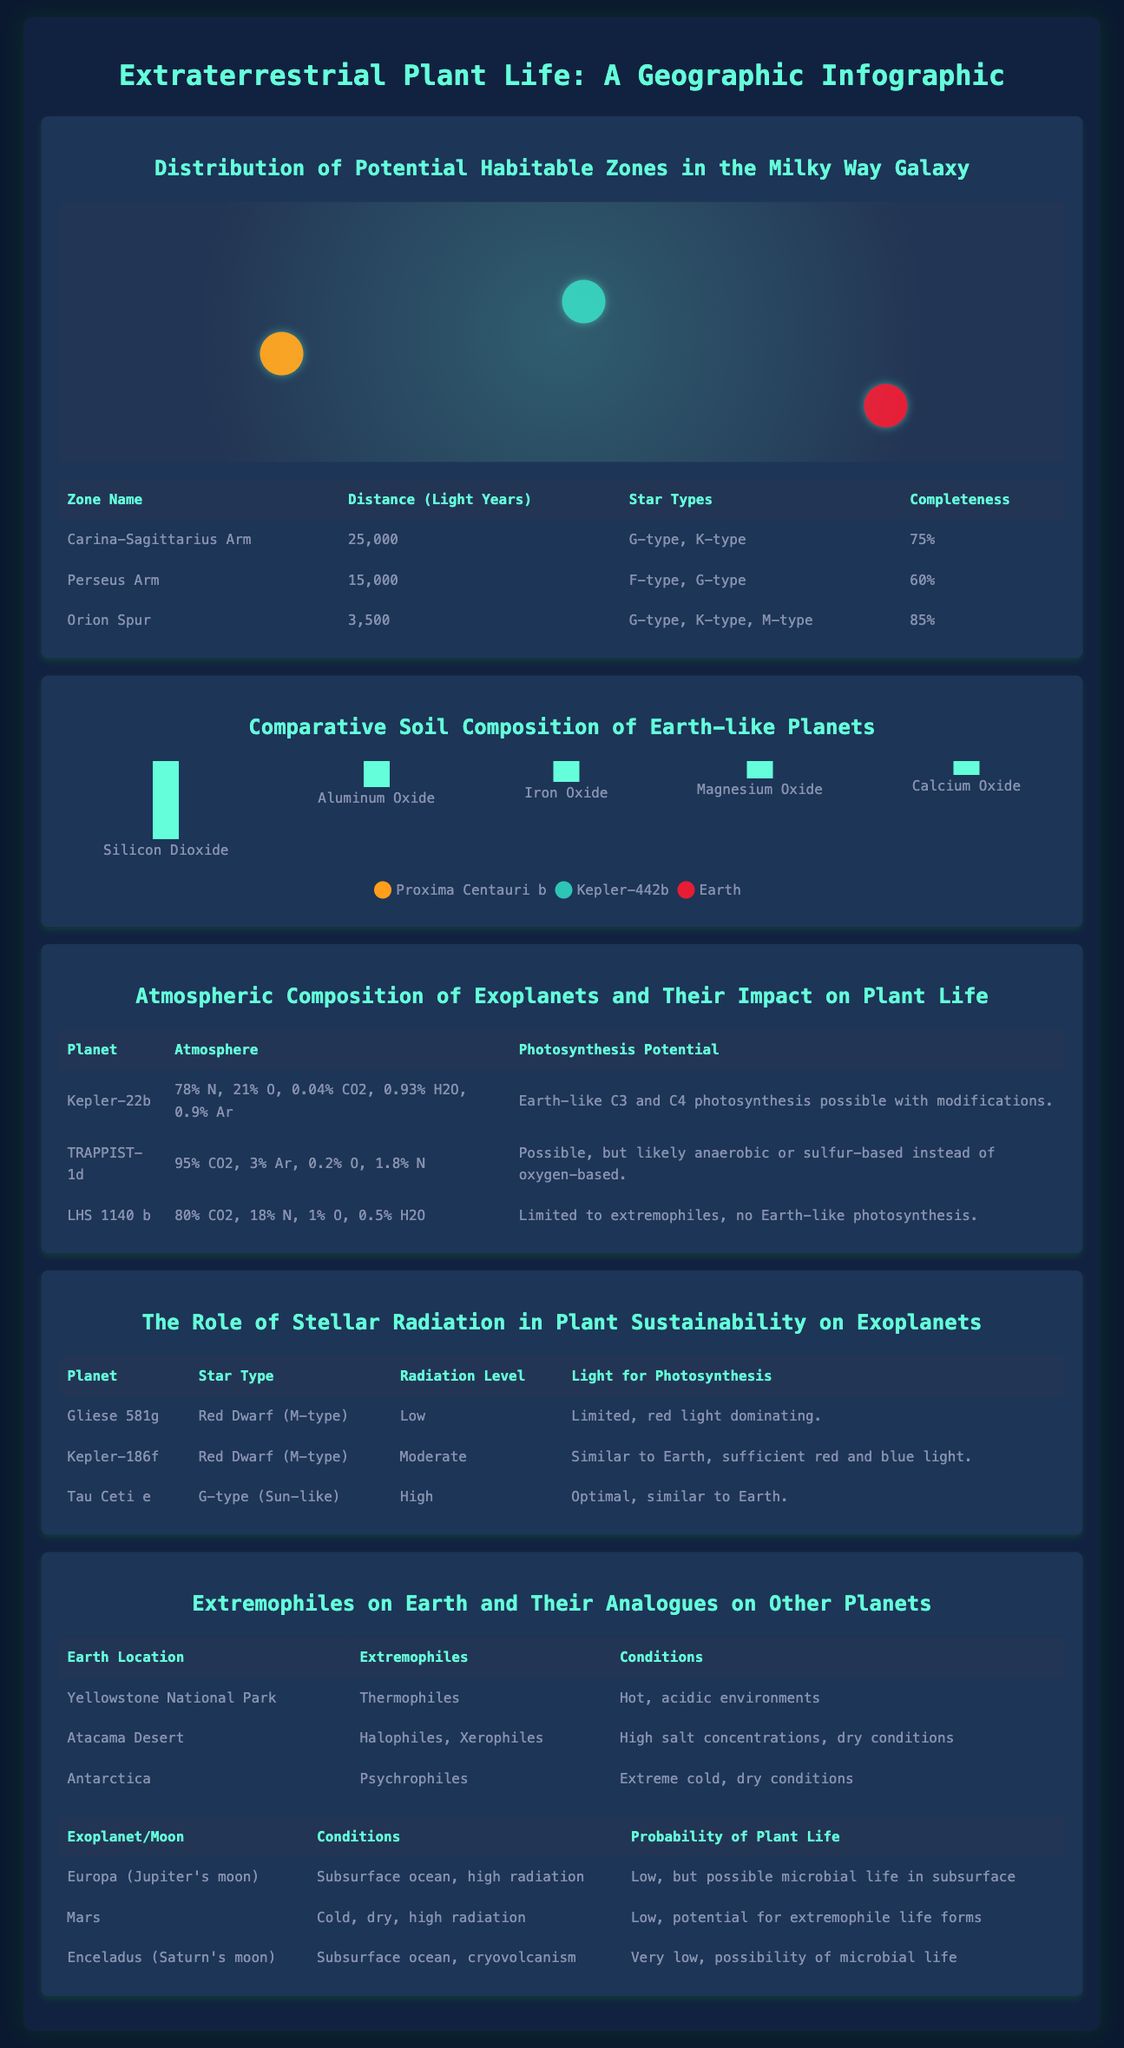What is the distance of the Orion Spur from Earth? The distance of the Orion Spur is noted in the 'Distribution of Potential Habitable Zones in the Milky Way Galaxy' section as 3,500 light years.
Answer: 3,500 light years Which exoplanet features a significant percentage of CO2 in its atmosphere? In the 'Atmospheric Composition of Exoplanets and Their Impact on Plant Life' section, TRAPPIST-1d is noted to have 95% CO2 in its atmosphere.
Answer: TRAPPIST-1d How many types of soil compositions are detailed in the infographic? The 'Comparative Soil Composition of Earth-like Planets' section includes five different types of soil compositions.
Answer: Five What is the primary star type of Tau Ceti e? In the 'The Role of Stellar Radiation in Plant Sustainability on Exoplanets' section, Tau Ceti e is identified as a G-type star, which is sun-like.
Answer: G-type What kind of extremophiles are found in the Atacama Desert? The extremophiles found in the Atacama Desert are noted as Halophiles and Xerophiles in the 'Extremophiles on Earth and Their Analogues on Other Planets' section.
Answer: Halophiles, Xerophiles Which planet has a probability of plant life as "Very low"? The planet Enceladus is marked with a "Very low" probability of plant life in the 'Extremophiles on Earth and Their Analogues on Other Planets' section.
Answer: Enceladus What radiation level does Gliese 581g exhibit? According to the 'The Role of Stellar Radiation in Plant Sustainability on Exoplanets', Gliese 581g is stated to have a low radiation level.
Answer: Low How many exoplanets are mentioned in the atmospheric composition section? The 'Atmospheric Composition of Exoplanets and Their Impact on Plant Life' section references three exoplanets.
Answer: Three 